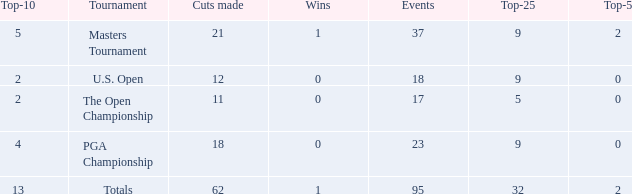Would you mind parsing the complete table? {'header': ['Top-10', 'Tournament', 'Cuts made', 'Wins', 'Events', 'Top-25', 'Top-5'], 'rows': [['5', 'Masters Tournament', '21', '1', '37', '9', '2'], ['2', 'U.S. Open', '12', '0', '18', '9', '0'], ['2', 'The Open Championship', '11', '0', '17', '5', '0'], ['4', 'PGA Championship', '18', '0', '23', '9', '0'], ['13', 'Totals', '62', '1', '95', '32', '2']]} What is the number of wins that is in the top 10 and larger than 13? None. 